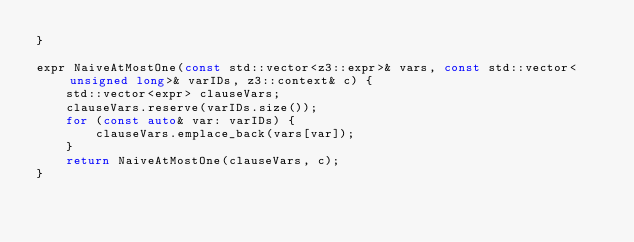<code> <loc_0><loc_0><loc_500><loc_500><_C++_>}

expr NaiveAtMostOne(const std::vector<z3::expr>& vars, const std::vector<unsigned long>& varIDs, z3::context& c) {
    std::vector<expr> clauseVars;
    clauseVars.reserve(varIDs.size());
    for (const auto& var: varIDs) {
        clauseVars.emplace_back(vars[var]);
    }
    return NaiveAtMostOne(clauseVars, c);
}
</code> 